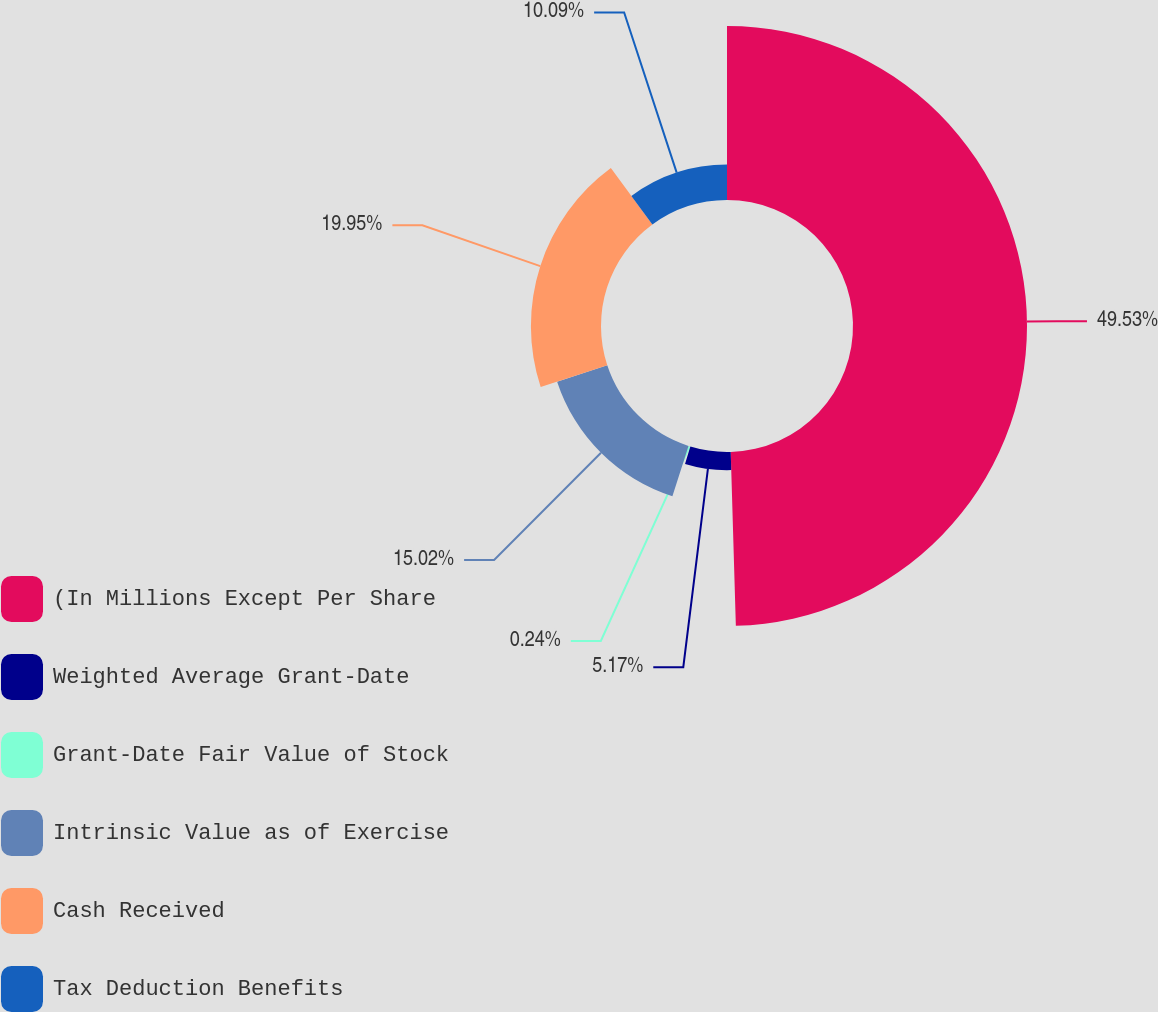Convert chart. <chart><loc_0><loc_0><loc_500><loc_500><pie_chart><fcel>(In Millions Except Per Share<fcel>Weighted Average Grant-Date<fcel>Grant-Date Fair Value of Stock<fcel>Intrinsic Value as of Exercise<fcel>Cash Received<fcel>Tax Deduction Benefits<nl><fcel>49.53%<fcel>5.17%<fcel>0.24%<fcel>15.02%<fcel>19.95%<fcel>10.09%<nl></chart> 